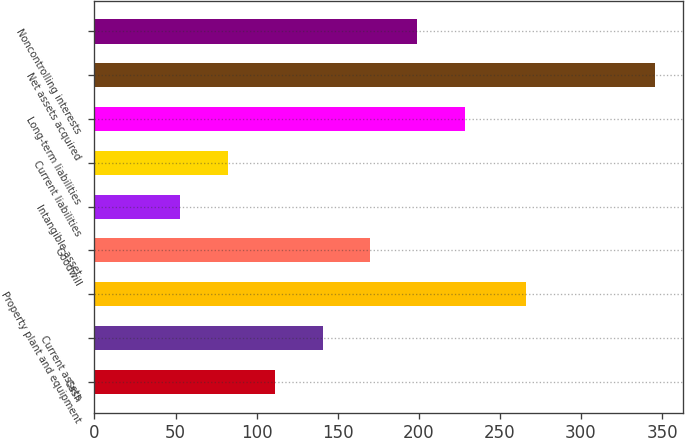Convert chart. <chart><loc_0><loc_0><loc_500><loc_500><bar_chart><fcel>Cash<fcel>Current assets<fcel>Property plant and equipment<fcel>Goodwill<fcel>Intangible asset<fcel>Current liabilities<fcel>Long-term liabilities<fcel>Net assets acquired<fcel>Noncontrolling interests<nl><fcel>111.36<fcel>140.64<fcel>265.9<fcel>169.92<fcel>52.8<fcel>82.08<fcel>228.48<fcel>345.6<fcel>199.2<nl></chart> 